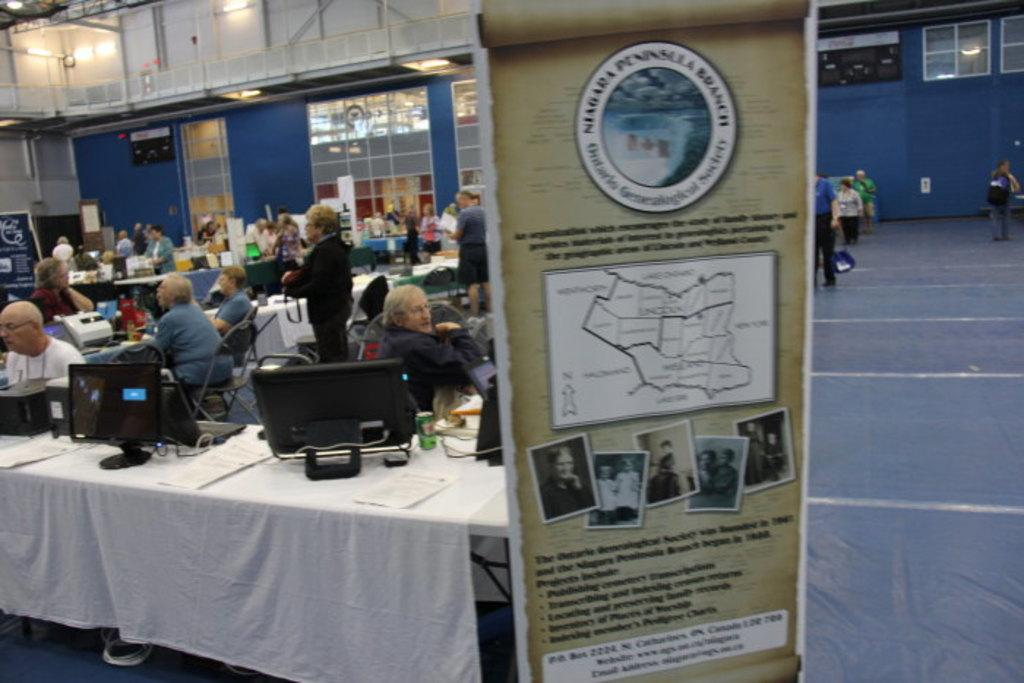<image>
Present a compact description of the photo's key features. People are gathered at a conference at the Niagara Peninsula Branch. 